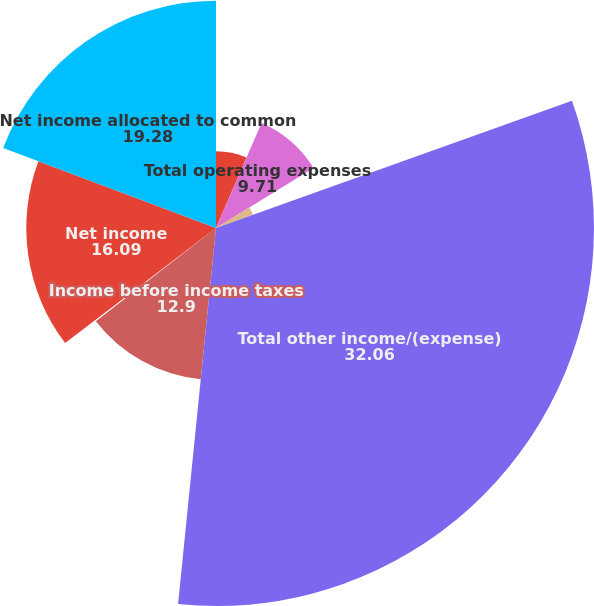Convert chart to OTSL. <chart><loc_0><loc_0><loc_500><loc_500><pie_chart><fcel>Total operating revenues<fcel>Total operating expenses<fcel>Operating income<fcel>Total other income/(expense)<fcel>Income before income taxes<fcel>Income tax provision<fcel>Net income<fcel>Net income allocated to common<nl><fcel>6.51%<fcel>9.71%<fcel>3.32%<fcel>32.06%<fcel>12.9%<fcel>0.13%<fcel>16.09%<fcel>19.28%<nl></chart> 